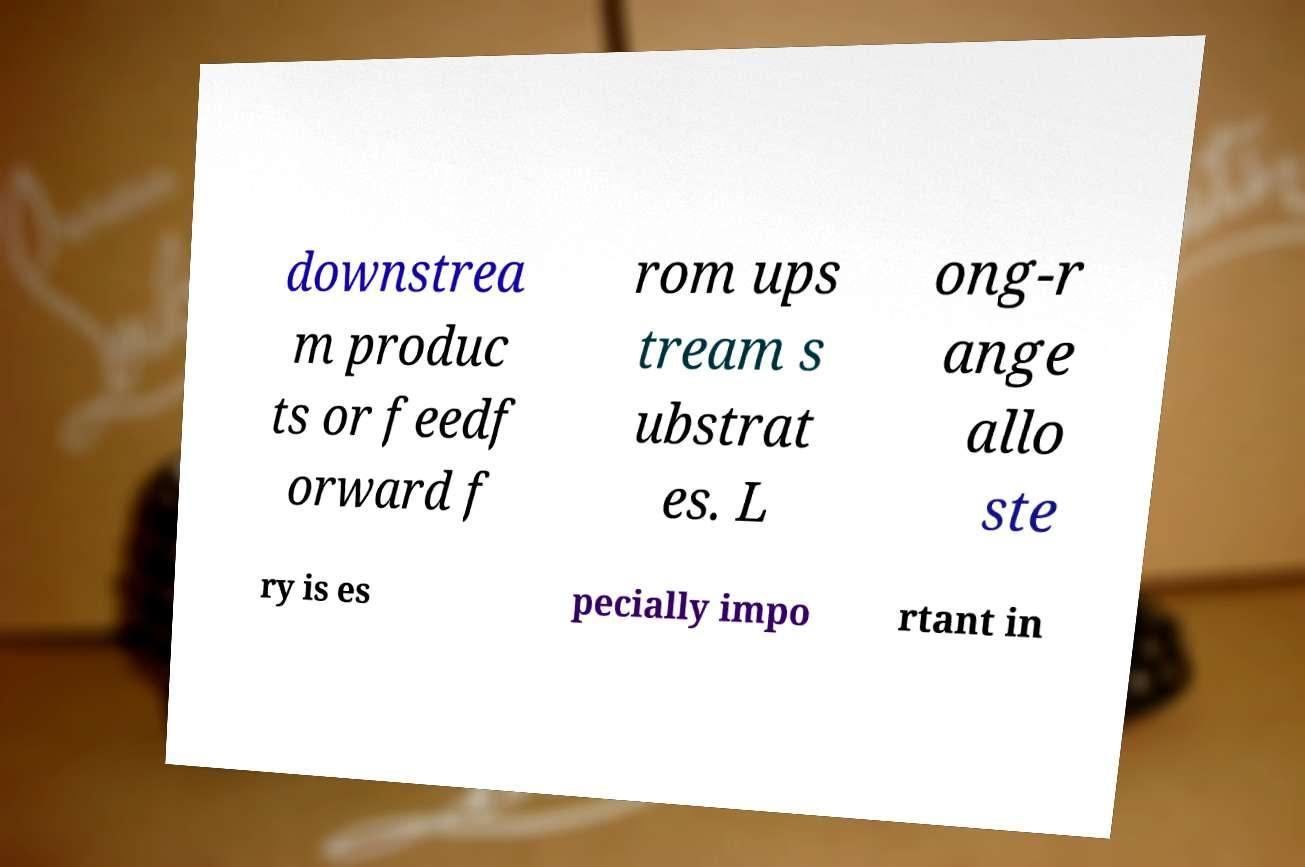Please identify and transcribe the text found in this image. downstrea m produc ts or feedf orward f rom ups tream s ubstrat es. L ong-r ange allo ste ry is es pecially impo rtant in 